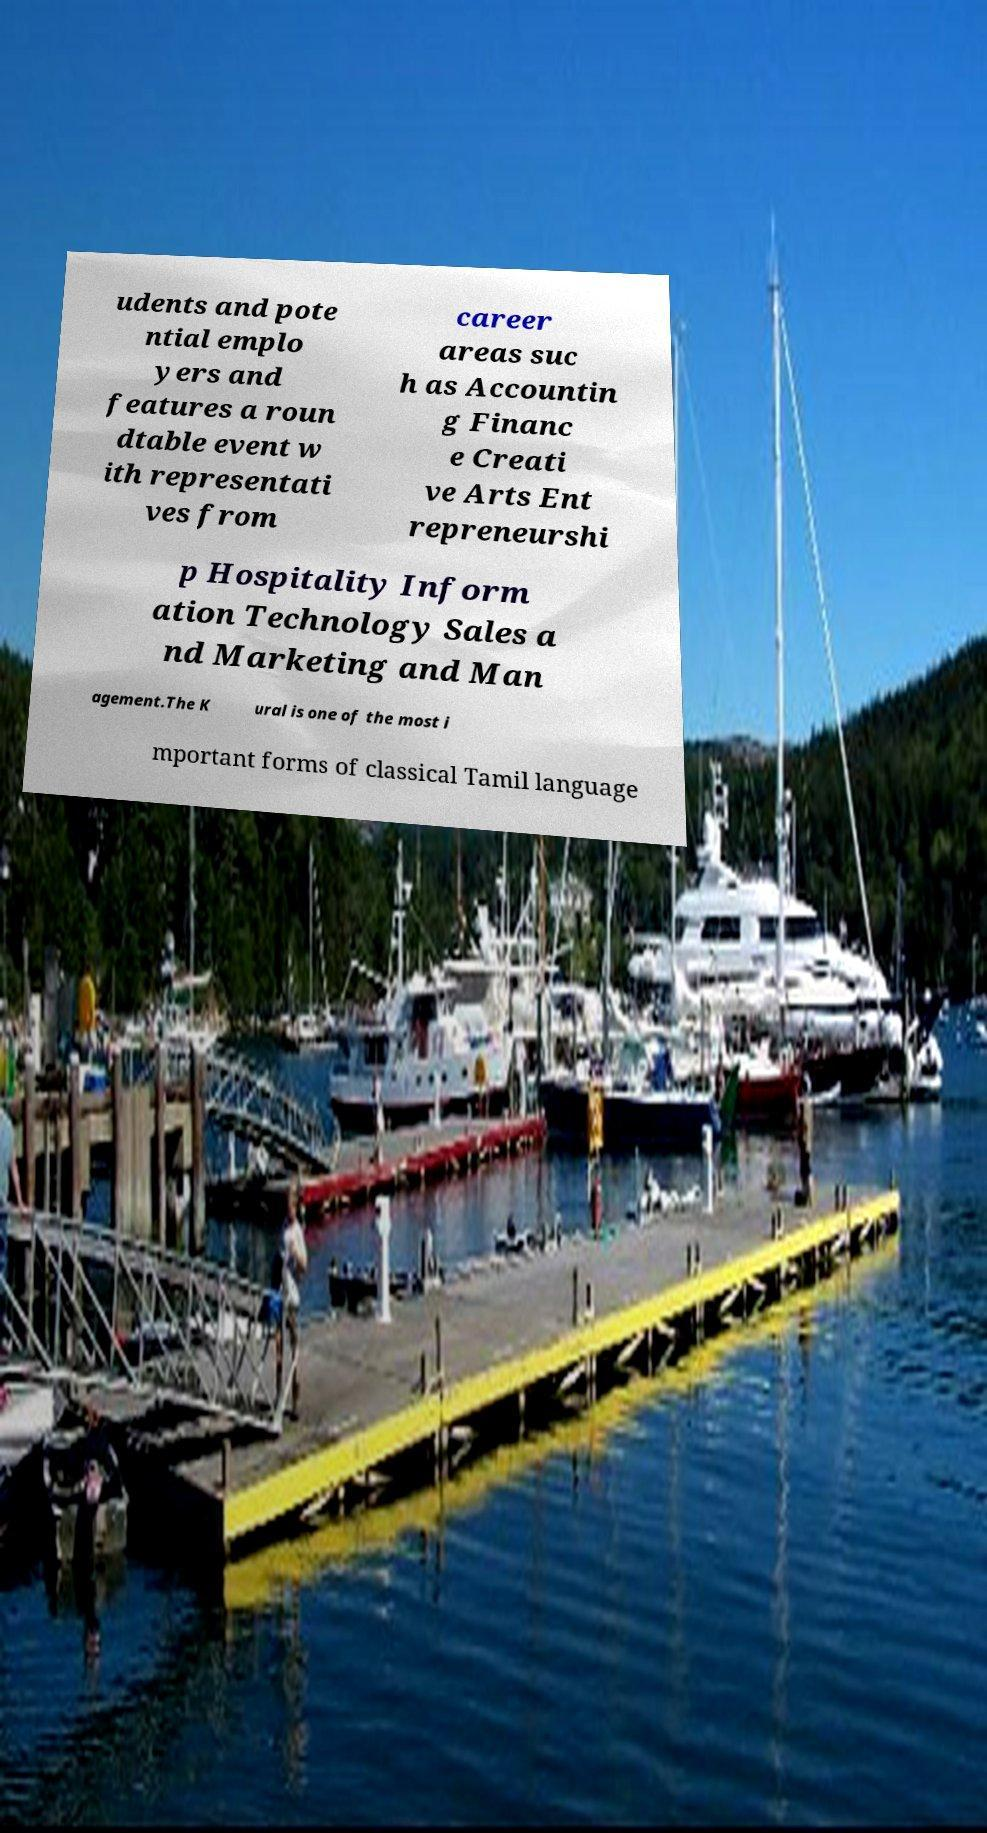Can you accurately transcribe the text from the provided image for me? udents and pote ntial emplo yers and features a roun dtable event w ith representati ves from career areas suc h as Accountin g Financ e Creati ve Arts Ent repreneurshi p Hospitality Inform ation Technology Sales a nd Marketing and Man agement.The K ural is one of the most i mportant forms of classical Tamil language 